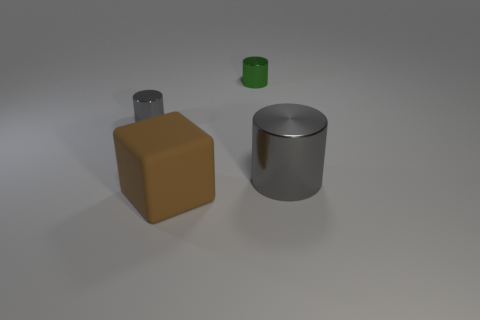Add 4 blue cylinders. How many objects exist? 8 Subtract all cylinders. How many objects are left? 1 Add 2 big brown rubber blocks. How many big brown rubber blocks exist? 3 Subtract 0 red blocks. How many objects are left? 4 Subtract all small green metallic objects. Subtract all green metal cylinders. How many objects are left? 2 Add 1 small green objects. How many small green objects are left? 2 